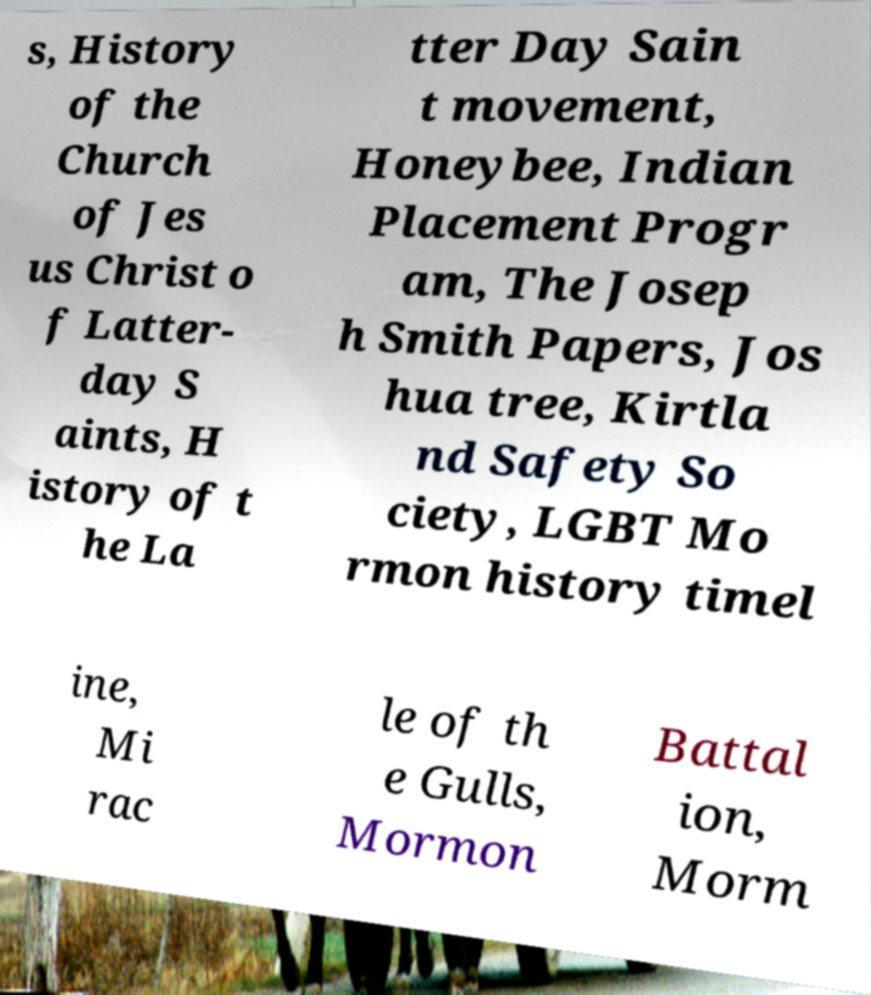Could you assist in decoding the text presented in this image and type it out clearly? s, History of the Church of Jes us Christ o f Latter- day S aints, H istory of t he La tter Day Sain t movement, Honeybee, Indian Placement Progr am, The Josep h Smith Papers, Jos hua tree, Kirtla nd Safety So ciety, LGBT Mo rmon history timel ine, Mi rac le of th e Gulls, Mormon Battal ion, Morm 